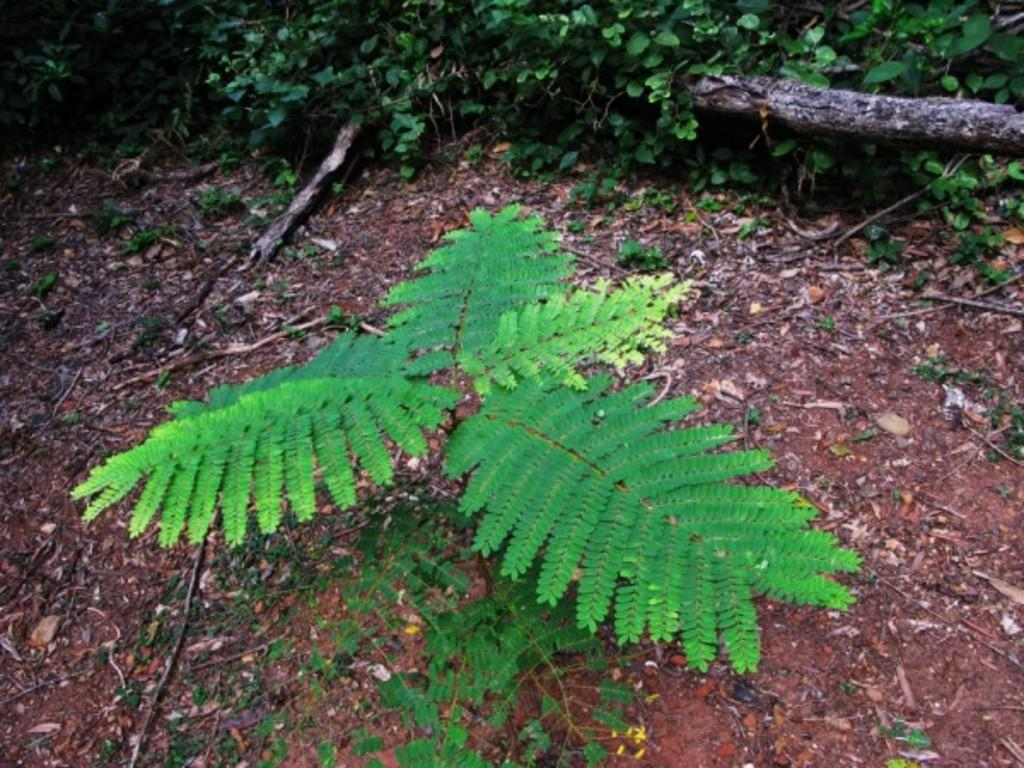What type of living organisms can be seen in the image? Plants can be seen in the image. What can be found on the ground in the image? There are twigs on the ground in the image. What type of plant is visible in the image? There are creepers in the image. What type of arithmetic problem is the monkey solving in the image? There is no monkey present in the image, so it cannot be solving any arithmetic problems. What type of cream is being used to decorate the plants in the image? There is no cream visible in the image; it only features plants, twigs, and creepers. 